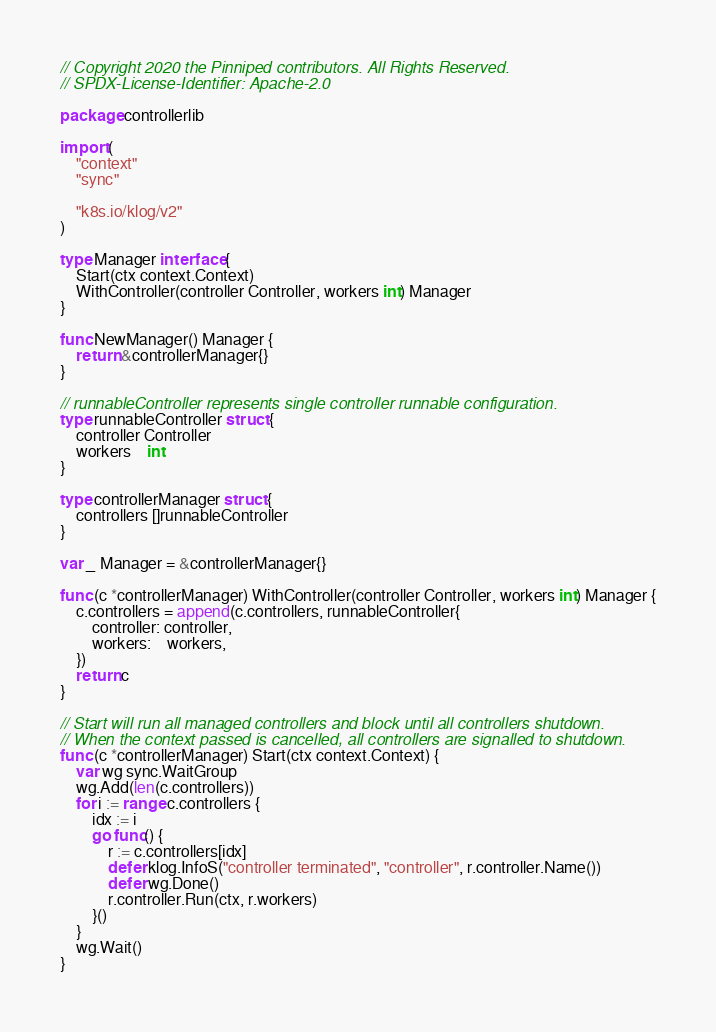Convert code to text. <code><loc_0><loc_0><loc_500><loc_500><_Go_>// Copyright 2020 the Pinniped contributors. All Rights Reserved.
// SPDX-License-Identifier: Apache-2.0

package controllerlib

import (
	"context"
	"sync"

	"k8s.io/klog/v2"
)

type Manager interface {
	Start(ctx context.Context)
	WithController(controller Controller, workers int) Manager
}

func NewManager() Manager {
	return &controllerManager{}
}

// runnableController represents single controller runnable configuration.
type runnableController struct {
	controller Controller
	workers    int
}

type controllerManager struct {
	controllers []runnableController
}

var _ Manager = &controllerManager{}

func (c *controllerManager) WithController(controller Controller, workers int) Manager {
	c.controllers = append(c.controllers, runnableController{
		controller: controller,
		workers:    workers,
	})
	return c
}

// Start will run all managed controllers and block until all controllers shutdown.
// When the context passed is cancelled, all controllers are signalled to shutdown.
func (c *controllerManager) Start(ctx context.Context) {
	var wg sync.WaitGroup
	wg.Add(len(c.controllers))
	for i := range c.controllers {
		idx := i
		go func() {
			r := c.controllers[idx]
			defer klog.InfoS("controller terminated", "controller", r.controller.Name())
			defer wg.Done()
			r.controller.Run(ctx, r.workers)
		}()
	}
	wg.Wait()
}
</code> 